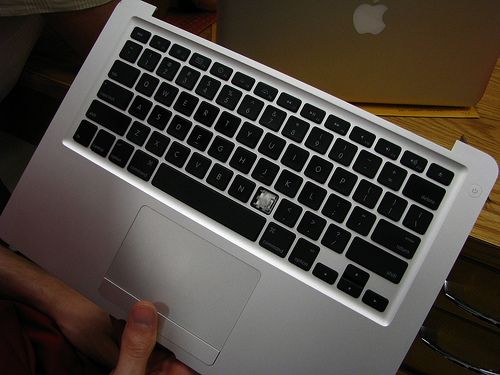<image>
Can you confirm if the finger is next to the space bar? No. The finger is not positioned next to the space bar. They are located in different areas of the scene. 